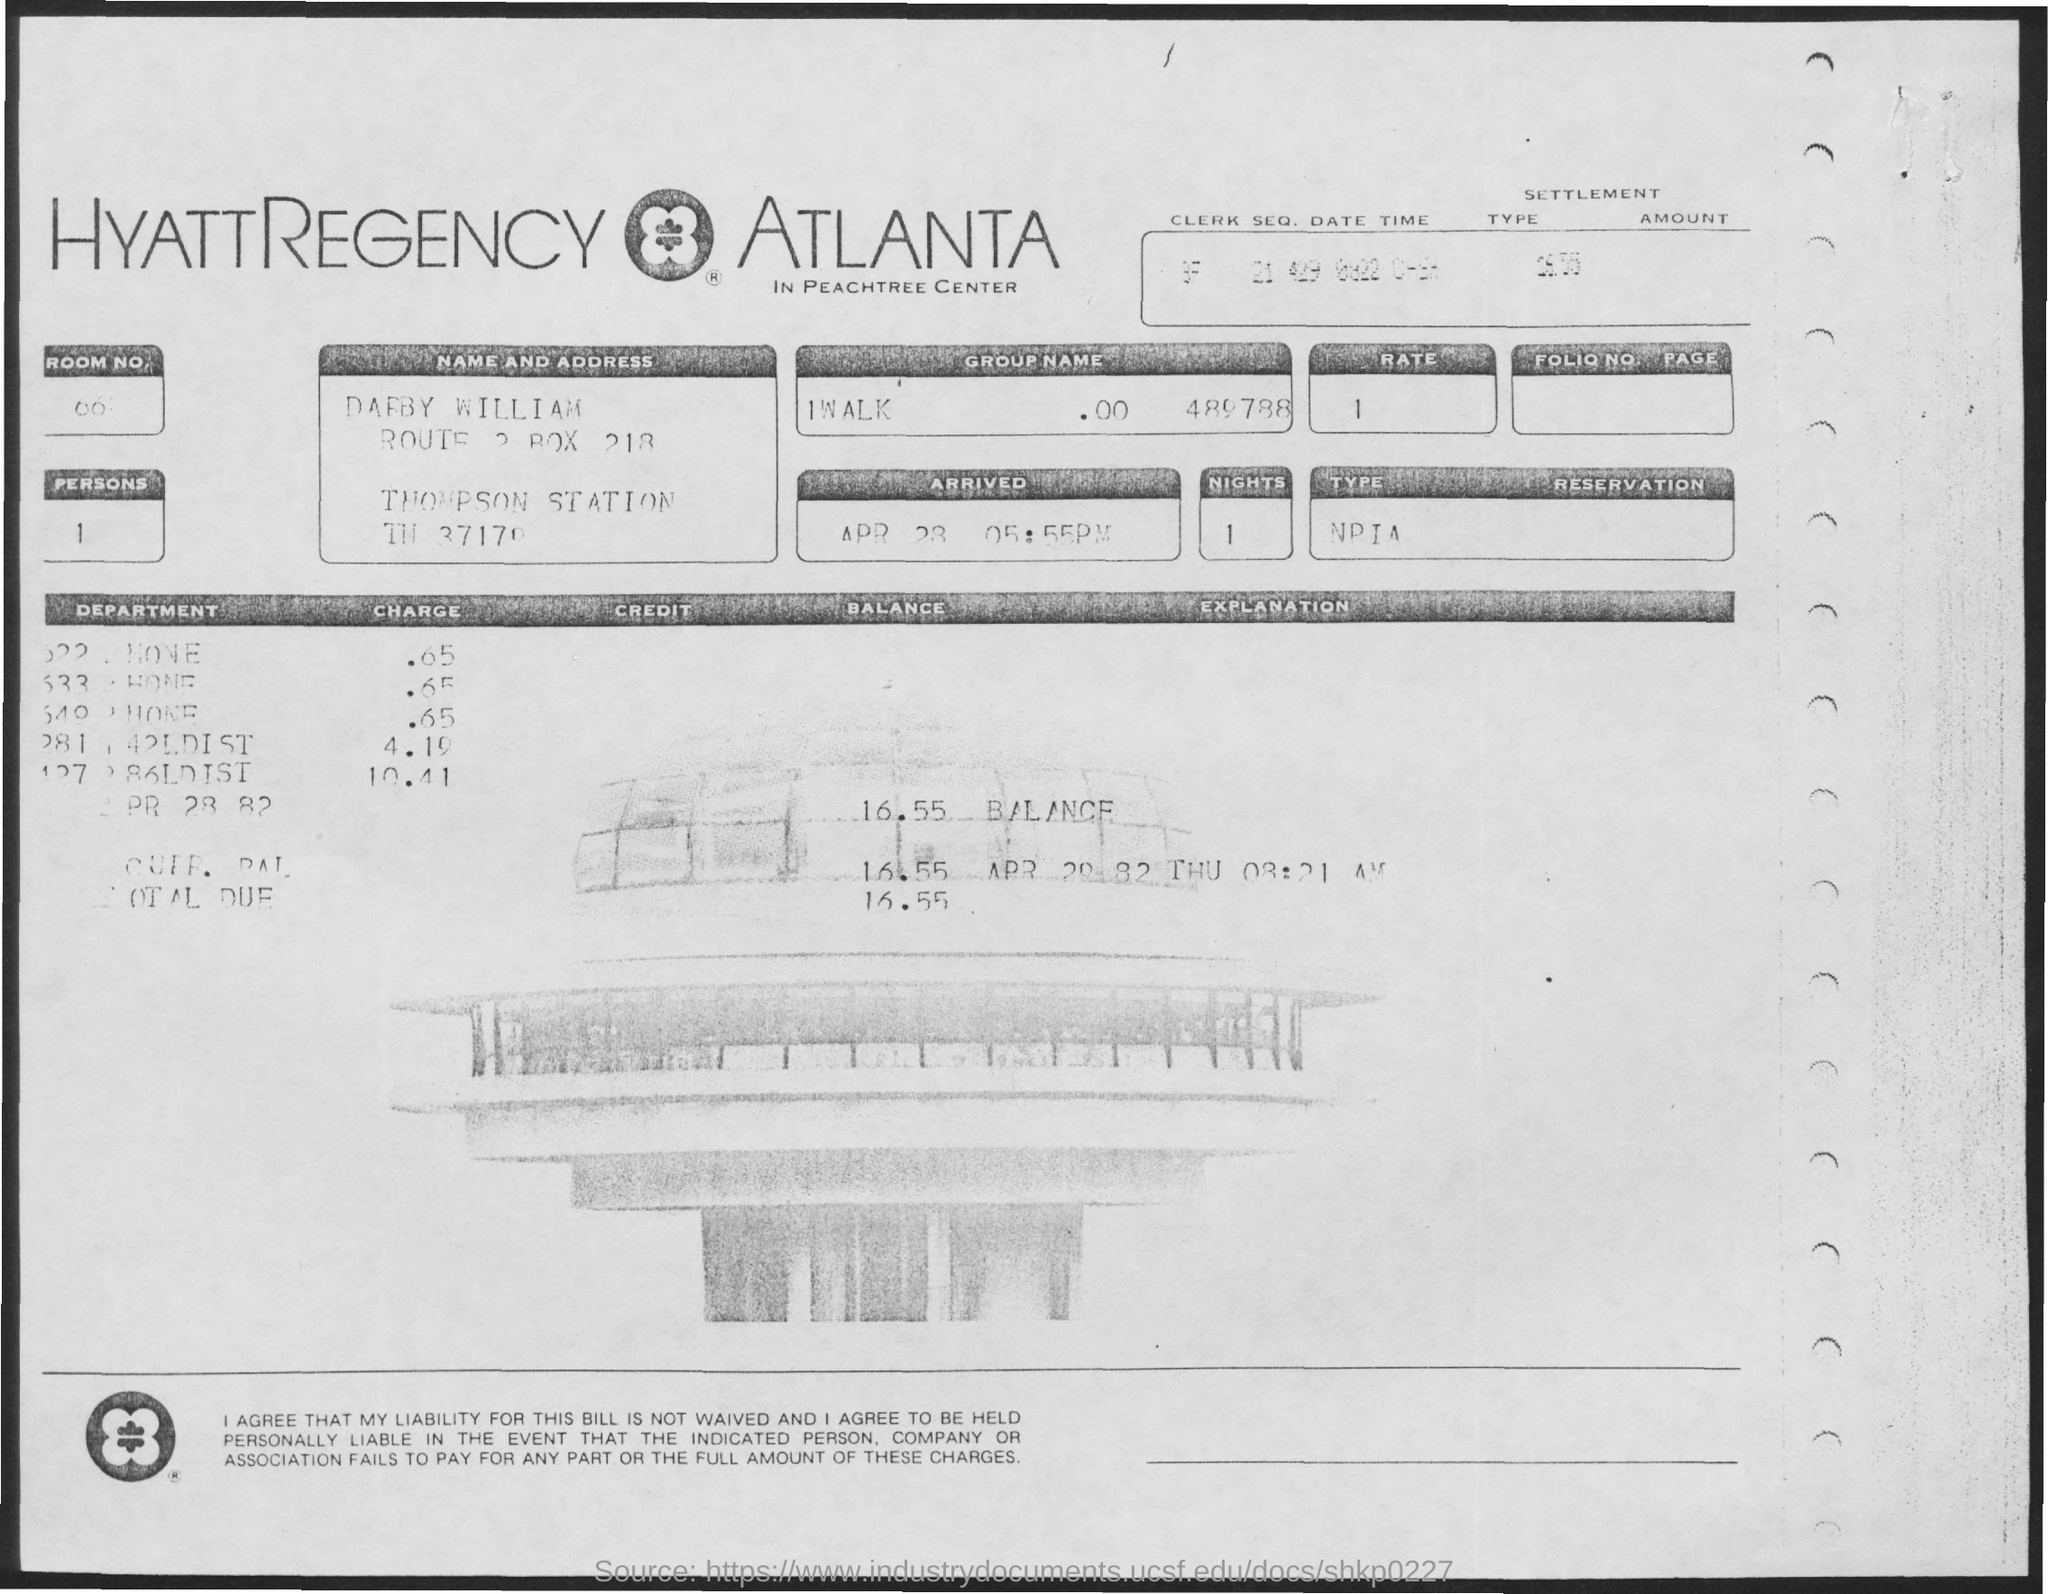What is the name of the person?
Offer a terse response. Darby william. What is the rate?
Offer a very short reply. 1. What is the number of persons?
Ensure brevity in your answer.  1. What is the number of nights?
Ensure brevity in your answer.  1. 